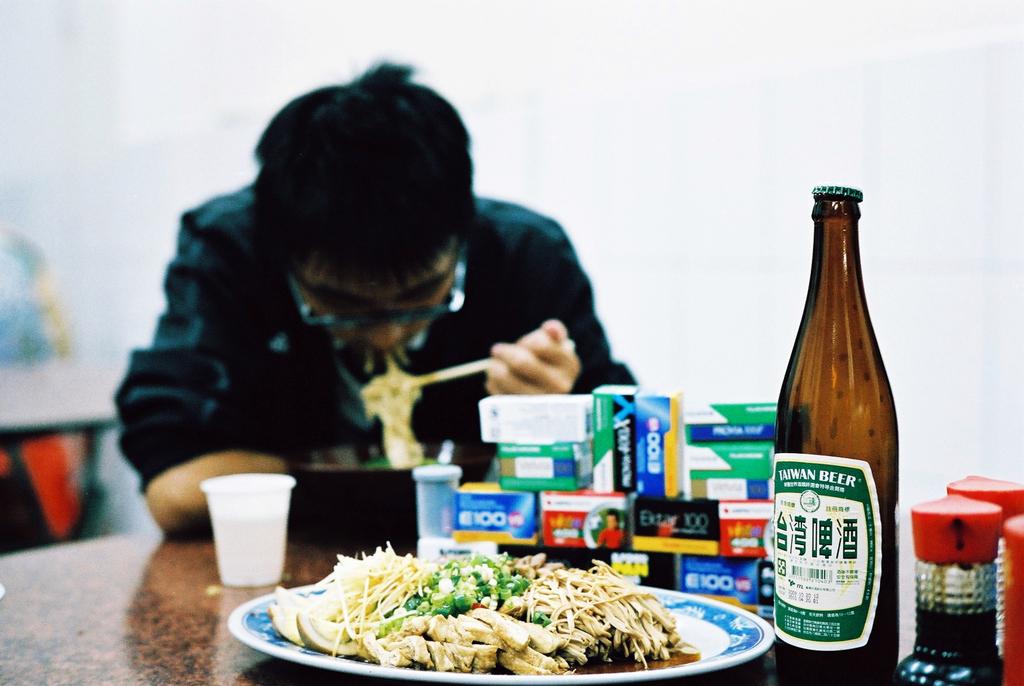What kind of beer?
Provide a short and direct response. Taiwan. 